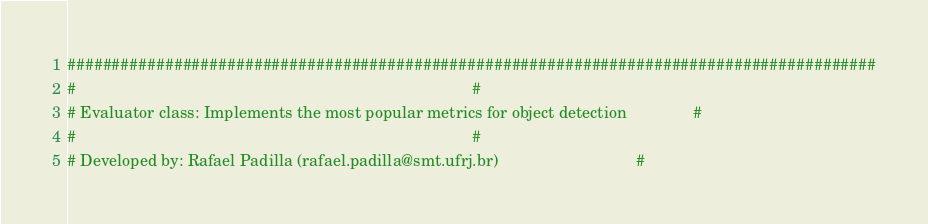<code> <loc_0><loc_0><loc_500><loc_500><_Python_>###########################################################################################
#                                                                                         #
# Evaluator class: Implements the most popular metrics for object detection               #
#                                                                                         #
# Developed by: Rafael Padilla (rafael.padilla@smt.ufrj.br)                               #</code> 